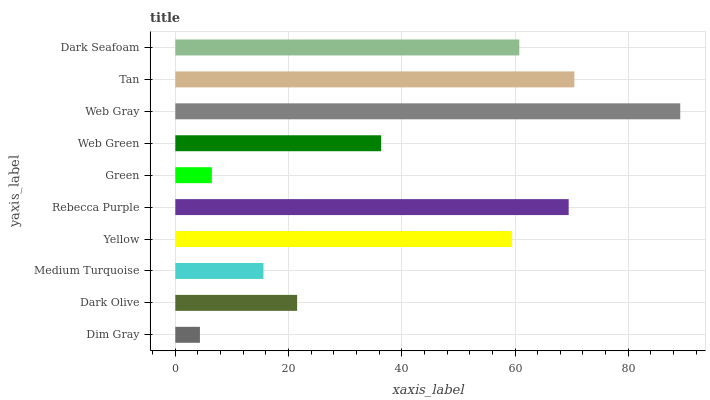Is Dim Gray the minimum?
Answer yes or no. Yes. Is Web Gray the maximum?
Answer yes or no. Yes. Is Dark Olive the minimum?
Answer yes or no. No. Is Dark Olive the maximum?
Answer yes or no. No. Is Dark Olive greater than Dim Gray?
Answer yes or no. Yes. Is Dim Gray less than Dark Olive?
Answer yes or no. Yes. Is Dim Gray greater than Dark Olive?
Answer yes or no. No. Is Dark Olive less than Dim Gray?
Answer yes or no. No. Is Yellow the high median?
Answer yes or no. Yes. Is Web Green the low median?
Answer yes or no. Yes. Is Rebecca Purple the high median?
Answer yes or no. No. Is Dark Seafoam the low median?
Answer yes or no. No. 